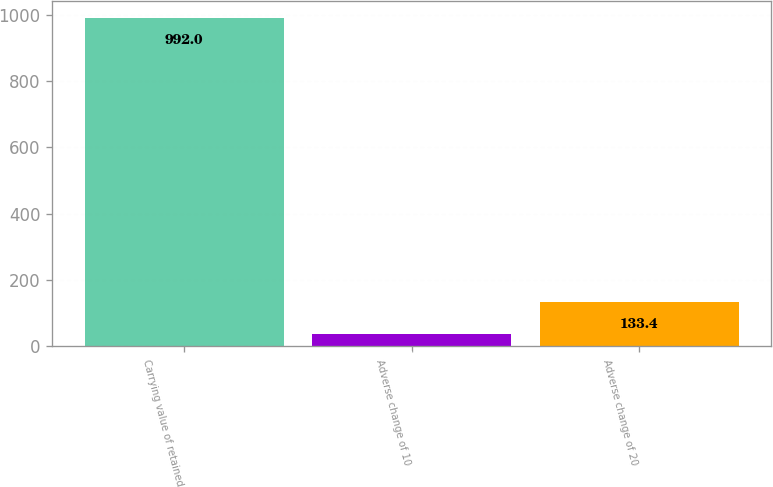Convert chart. <chart><loc_0><loc_0><loc_500><loc_500><bar_chart><fcel>Carrying value of retained<fcel>Adverse change of 10<fcel>Adverse change of 20<nl><fcel>992<fcel>38<fcel>133.4<nl></chart> 